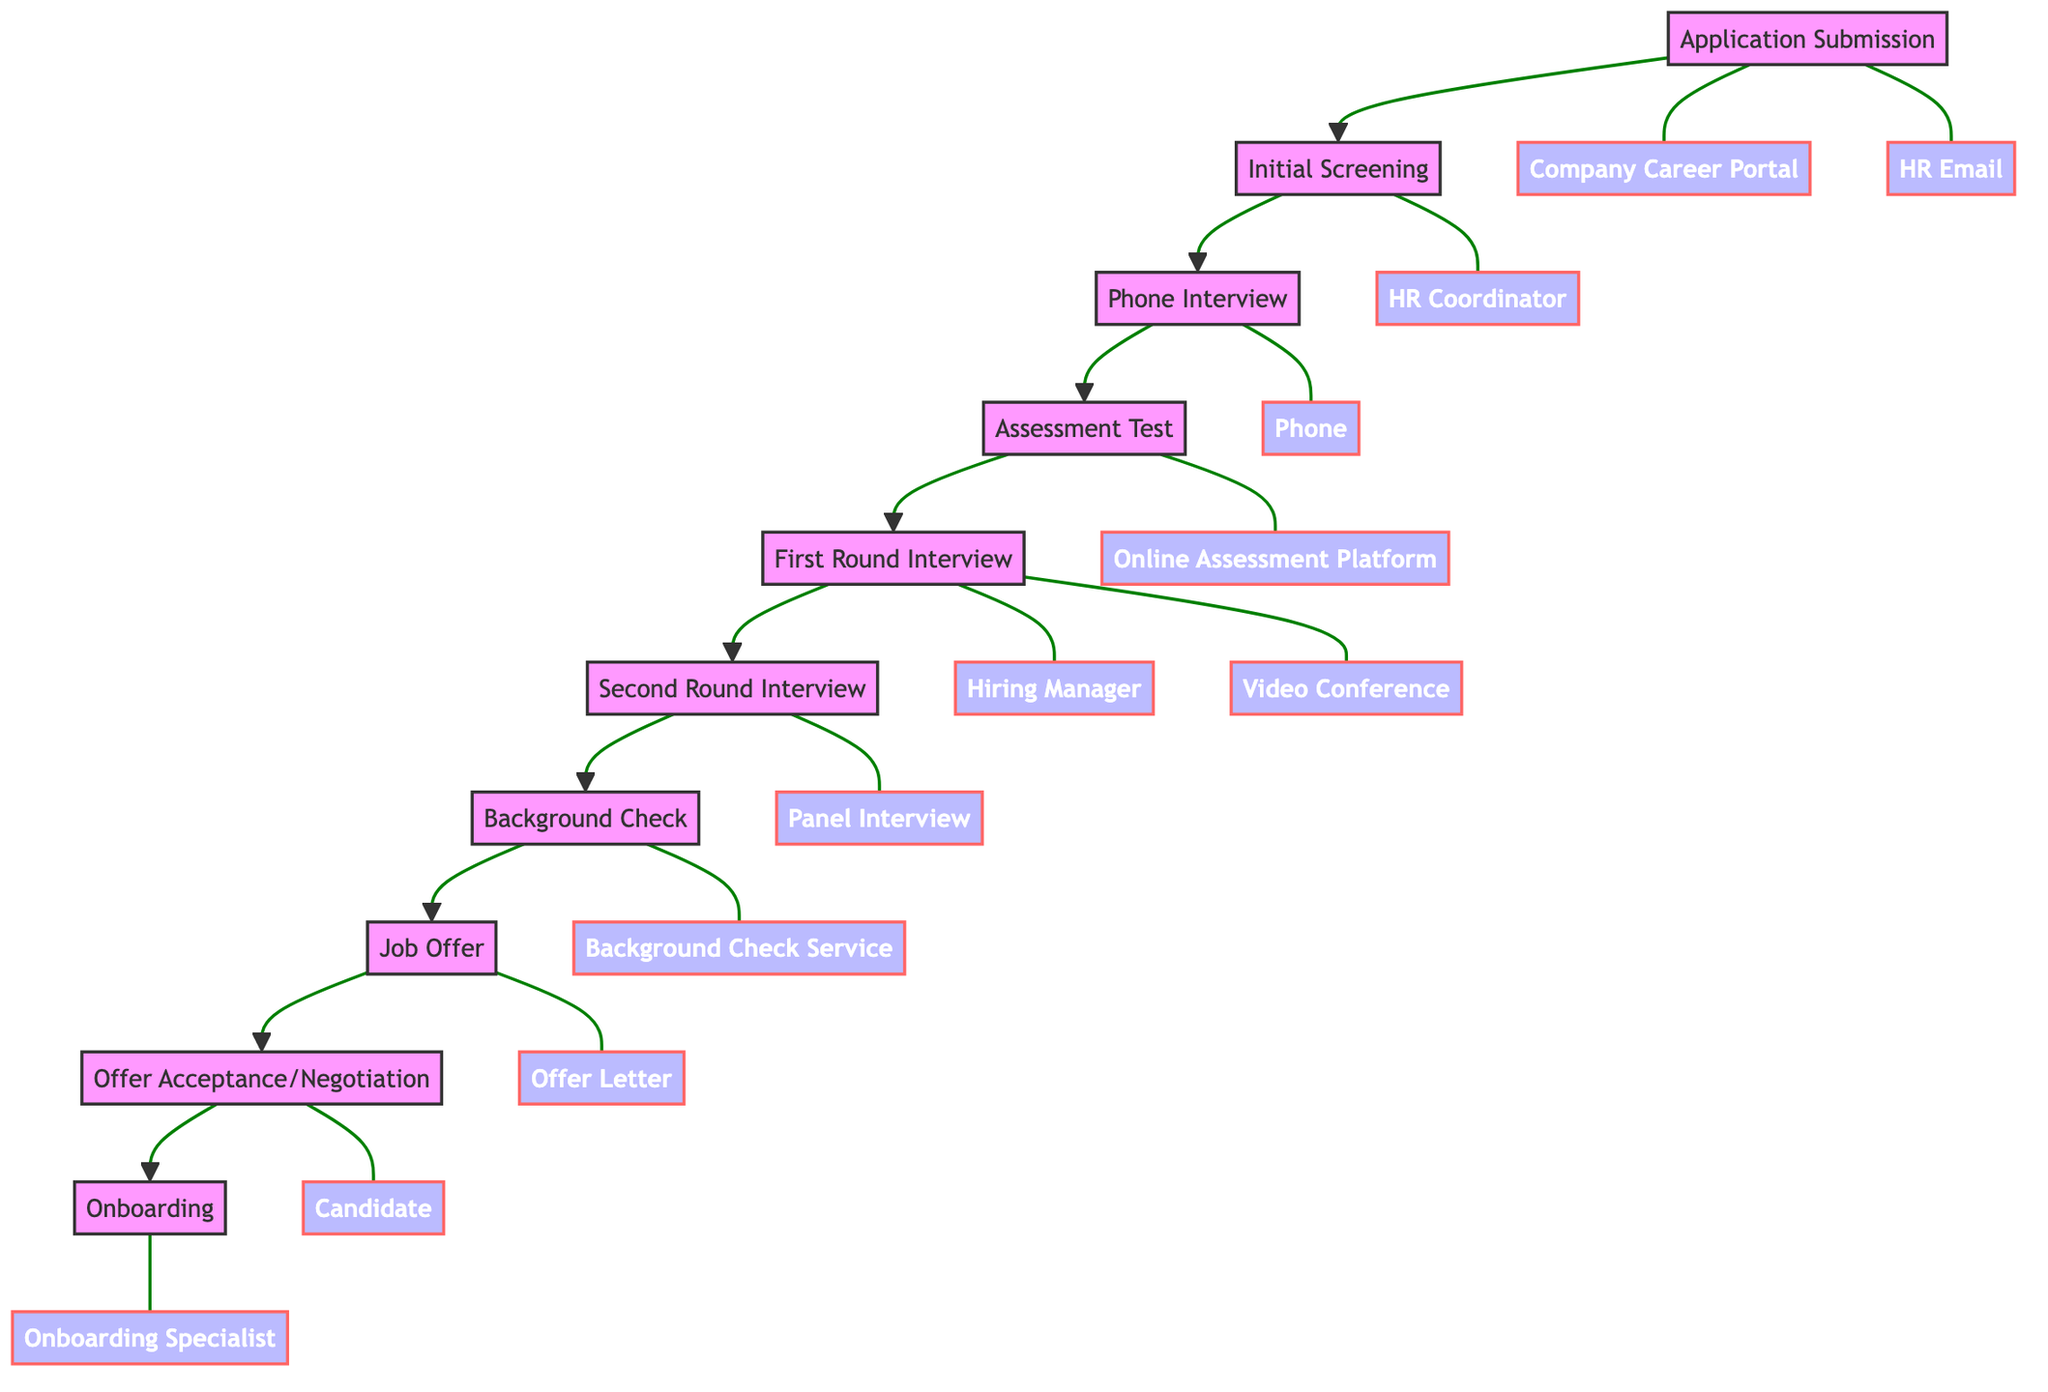What is the first step in the job application process? The diagram shows that the first step is "Application Submission." This can be identified as the node at the top of the flowchart that initiates the process.
Answer: Application Submission How many main steps are in the job application process? By counting the nodes in the diagram, there are ten main steps in the job application process, listed from "Application Submission" to "Onboarding."
Answer: Ten Which step follows the "Background Check"? The diagram indicates the step after "Background Check" is "Job Offer." This can be seen by checking the flow of arrows pointing down from "Background Check" to the next node.
Answer: Job Offer What entities are involved in the "First Round Interview"? The entities associated with "First Round Interview" include "Hiring Manager" and "Video Conference." These entities are linked directly to the "First Round Interview" node in the diagram.
Answer: Hiring Manager, Video Conference What action occurs just before "Onboarding"? The action that takes place just before "Onboarding" is "Offer Acceptance/Negotiation." You can determine this by tracing the flow from "Offer Acceptance/Negotiation" to "Onboarding."
Answer: Offer Acceptance/Negotiation How many entities are involved in the "Assessment Test"? There are two entities involved in the "Assessment Test": "Online Assessment Platform" and "HR Coordinator." This can be verified by checking the connections to the "Assessment Test" node.
Answer: Two Which step comes after "Second Round Interview"? The step that comes after "Second Round Interview" is "Background Check," which is shown as the next node in the flowchart following "Second Round Interview."
Answer: Background Check What is the final step in the application process? The final step in the job application process, as depicted in the diagram, is "Onboarding." This is the last node connected in the flow of the diagram.
Answer: Onboarding 